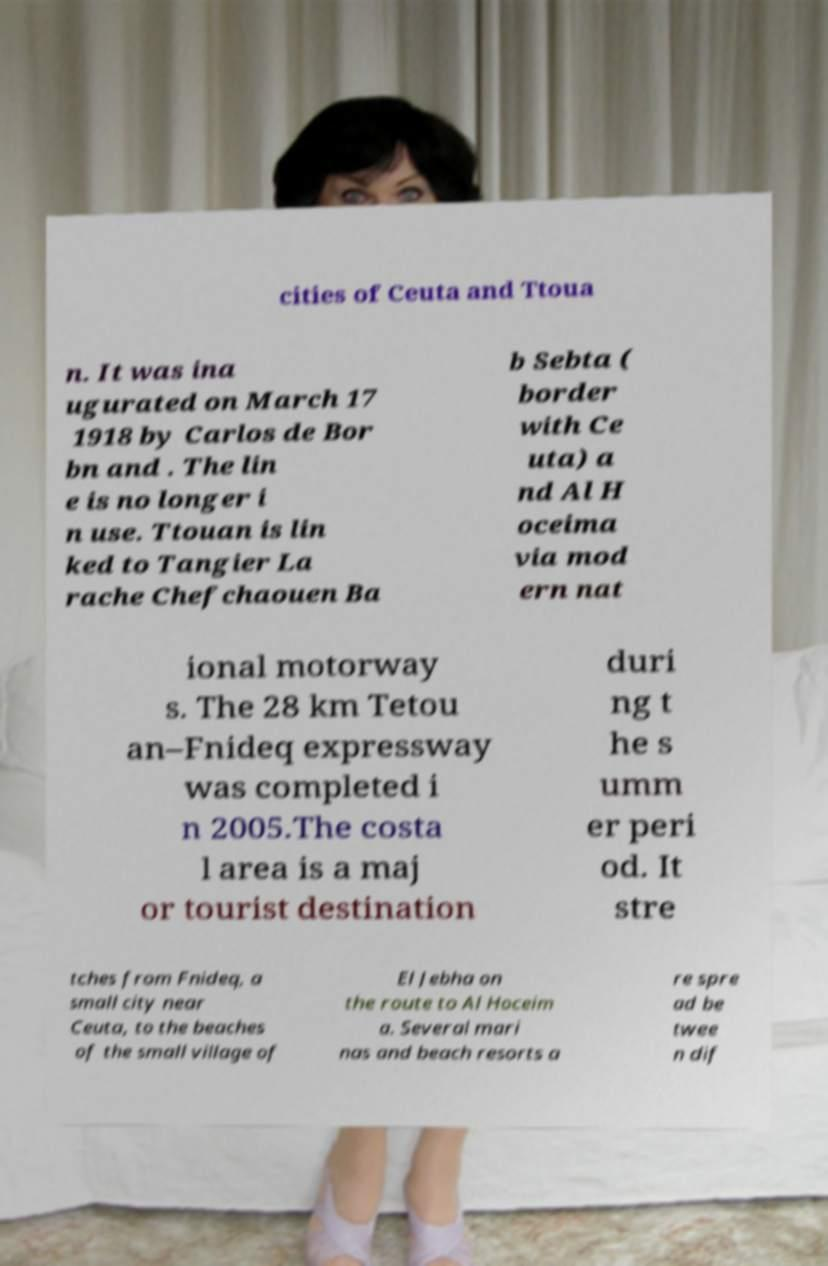I need the written content from this picture converted into text. Can you do that? cities of Ceuta and Ttoua n. It was ina ugurated on March 17 1918 by Carlos de Bor bn and . The lin e is no longer i n use. Ttouan is lin ked to Tangier La rache Chefchaouen Ba b Sebta ( border with Ce uta) a nd Al H oceima via mod ern nat ional motorway s. The 28 km Tetou an–Fnideq expressway was completed i n 2005.The costa l area is a maj or tourist destination duri ng t he s umm er peri od. It stre tches from Fnideq, a small city near Ceuta, to the beaches of the small village of El Jebha on the route to Al Hoceim a. Several mari nas and beach resorts a re spre ad be twee n dif 